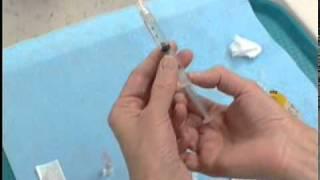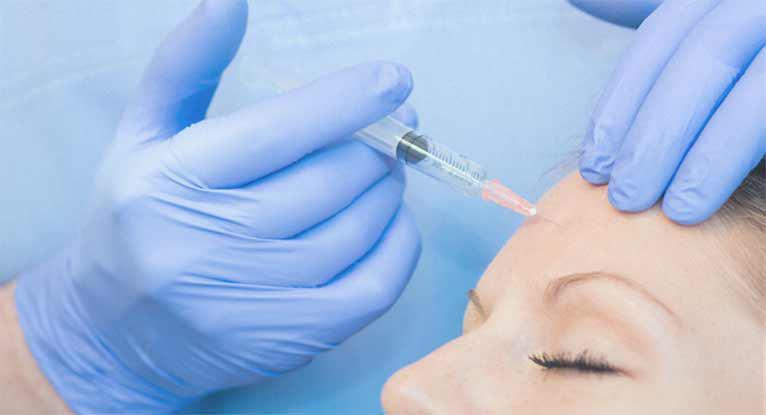The first image is the image on the left, the second image is the image on the right. Evaluate the accuracy of this statement regarding the images: "There are four bare hands working with needles.". Is it true? Answer yes or no. No. 